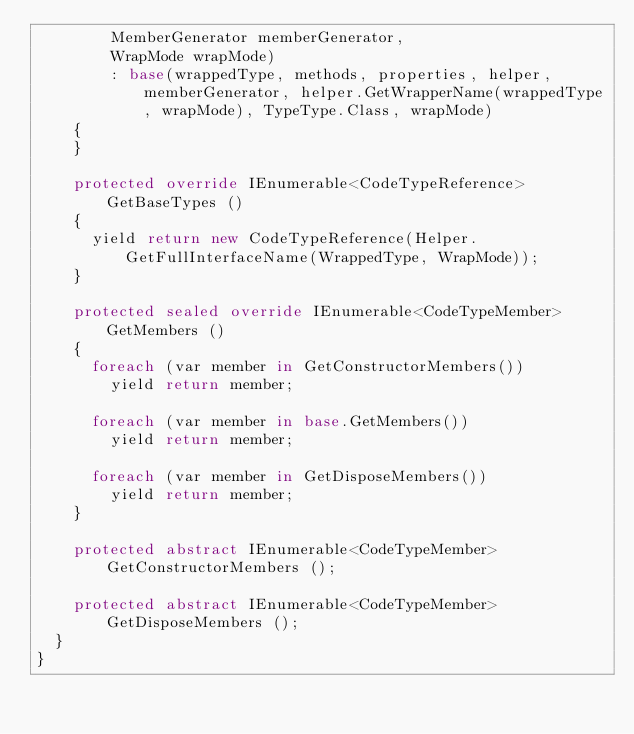<code> <loc_0><loc_0><loc_500><loc_500><_C#_>        MemberGenerator memberGenerator,
        WrapMode wrapMode)
        : base(wrappedType, methods, properties, helper, memberGenerator, helper.GetWrapperName(wrappedType, wrapMode), TypeType.Class, wrapMode)
    {
    }

    protected override IEnumerable<CodeTypeReference> GetBaseTypes ()
    {
      yield return new CodeTypeReference(Helper.GetFullInterfaceName(WrappedType, WrapMode));
    }

    protected sealed override IEnumerable<CodeTypeMember> GetMembers ()
    {
      foreach (var member in GetConstructorMembers())
        yield return member;

      foreach (var member in base.GetMembers())
        yield return member;

      foreach (var member in GetDisposeMembers())
        yield return member;
    }

    protected abstract IEnumerable<CodeTypeMember> GetConstructorMembers ();

    protected abstract IEnumerable<CodeTypeMember> GetDisposeMembers ();
  }
}</code> 